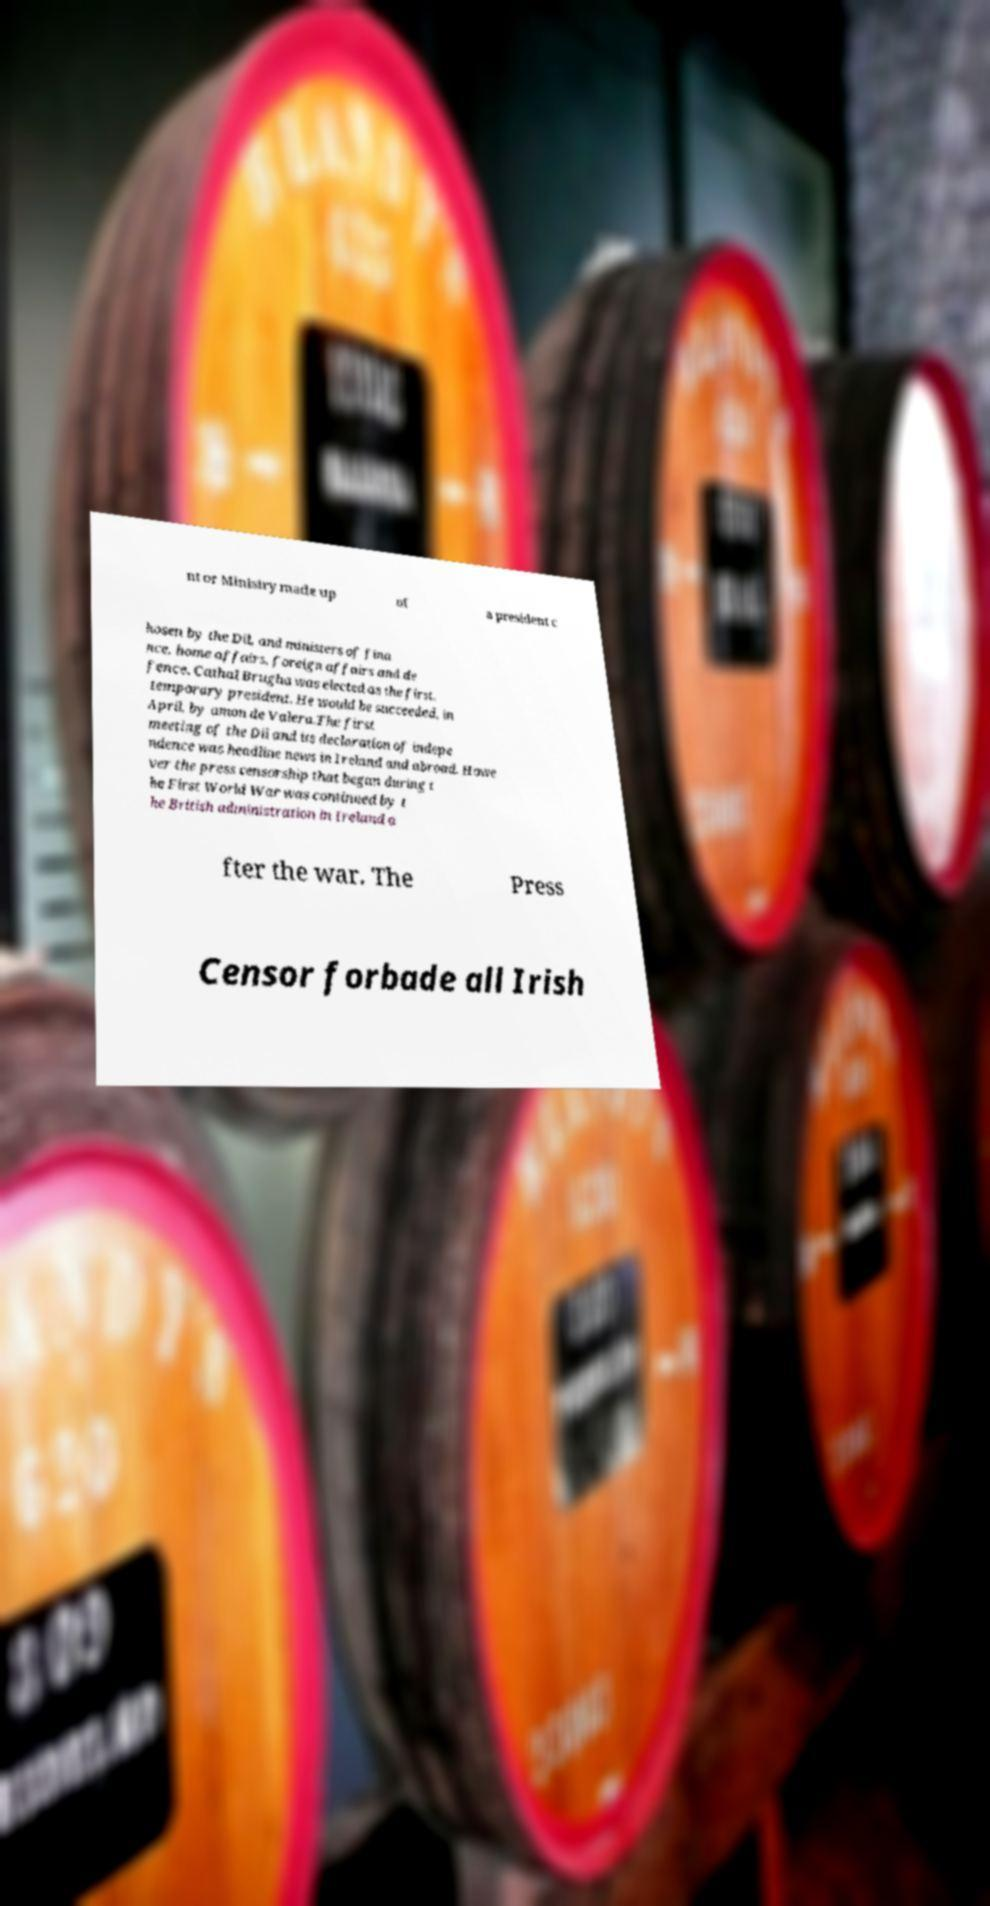For documentation purposes, I need the text within this image transcribed. Could you provide that? nt or Ministry made up of a president c hosen by the Dil, and ministers of fina nce, home affairs, foreign affairs and de fence. Cathal Brugha was elected as the first, temporary president. He would be succeeded, in April, by amon de Valera.The first meeting of the Dil and its declaration of indepe ndence was headline news in Ireland and abroad. Howe ver the press censorship that began during t he First World War was continued by t he British administration in Ireland a fter the war. The Press Censor forbade all Irish 